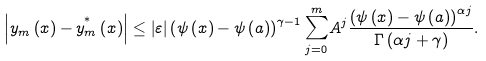<formula> <loc_0><loc_0><loc_500><loc_500>\left | y _ { m } \left ( x \right ) - \overset { \ast } { y _ { m } } \left ( x \right ) \right | \leq \left | \varepsilon \right | \left ( \psi \left ( x \right ) - \psi \left ( a \right ) \right ) ^ { \gamma - 1 } \overset { m } { \underset { j = 0 } { \sum } } A ^ { j } \frac { \left ( \psi \left ( x \right ) - \psi \left ( a \right ) \right ) ^ { \alpha j } } { \Gamma \left ( \alpha j + \gamma \right ) } .</formula> 